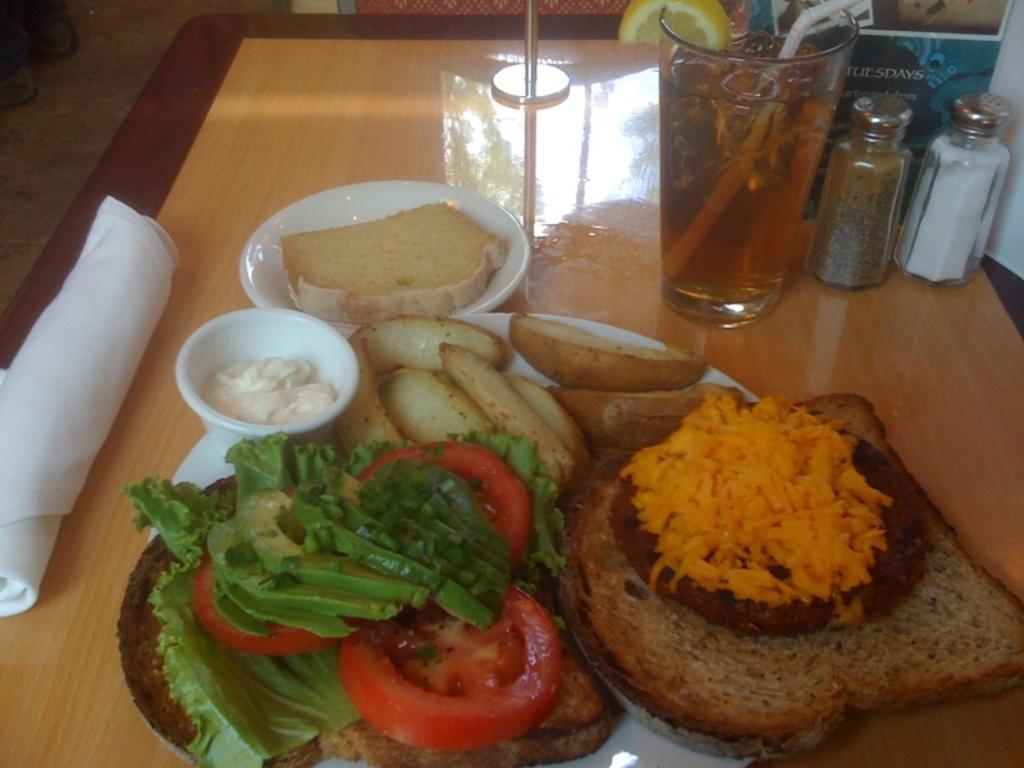In one or two sentences, can you explain what this image depicts? There are leaves, tomato pieces, cakes, cream in the white color cup and other food items on the white color plate, which is on the table, on which, there is a glass filled with drink, two bottles, white color paper and other objects. 